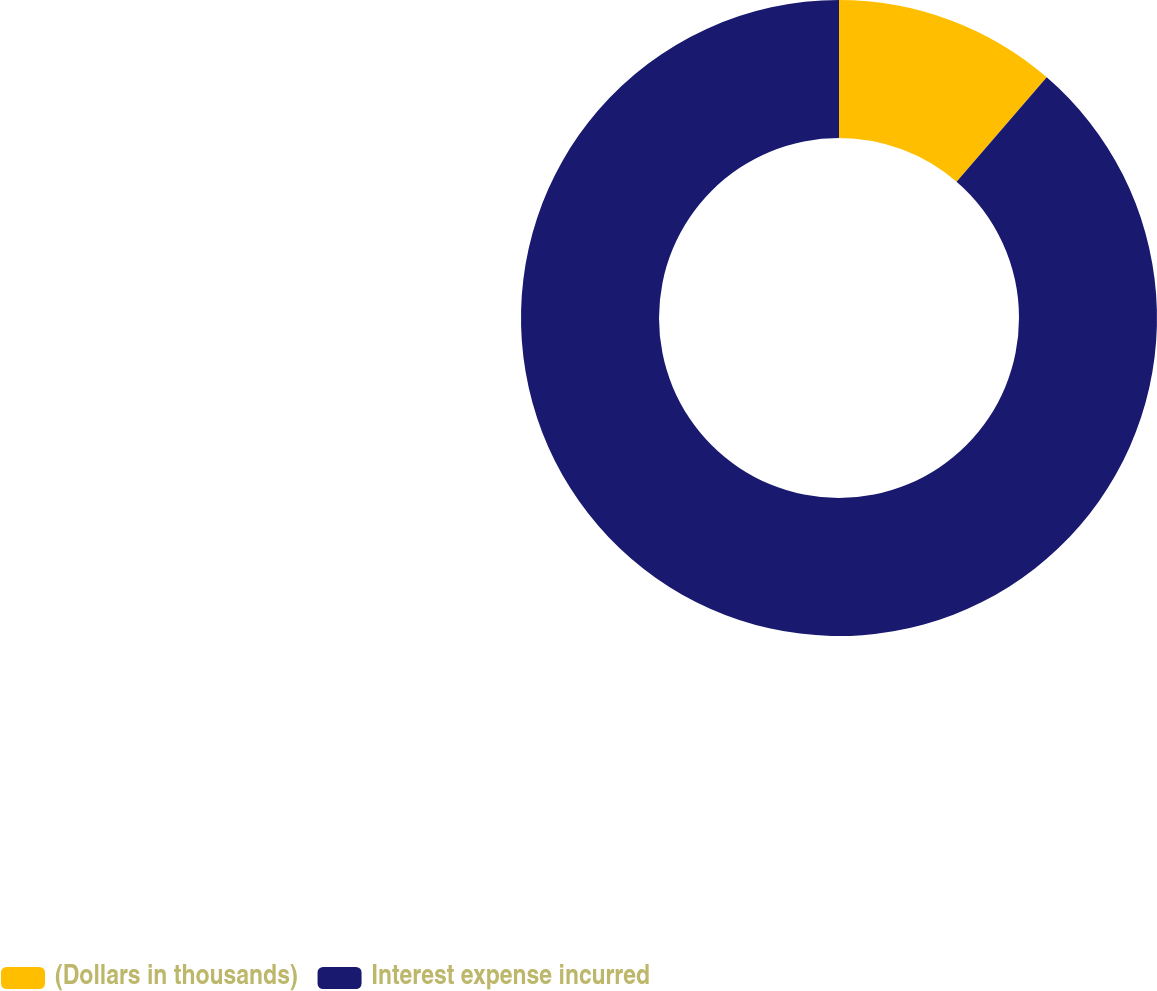Convert chart. <chart><loc_0><loc_0><loc_500><loc_500><pie_chart><fcel>(Dollars in thousands)<fcel>Interest expense incurred<nl><fcel>11.33%<fcel>88.67%<nl></chart> 